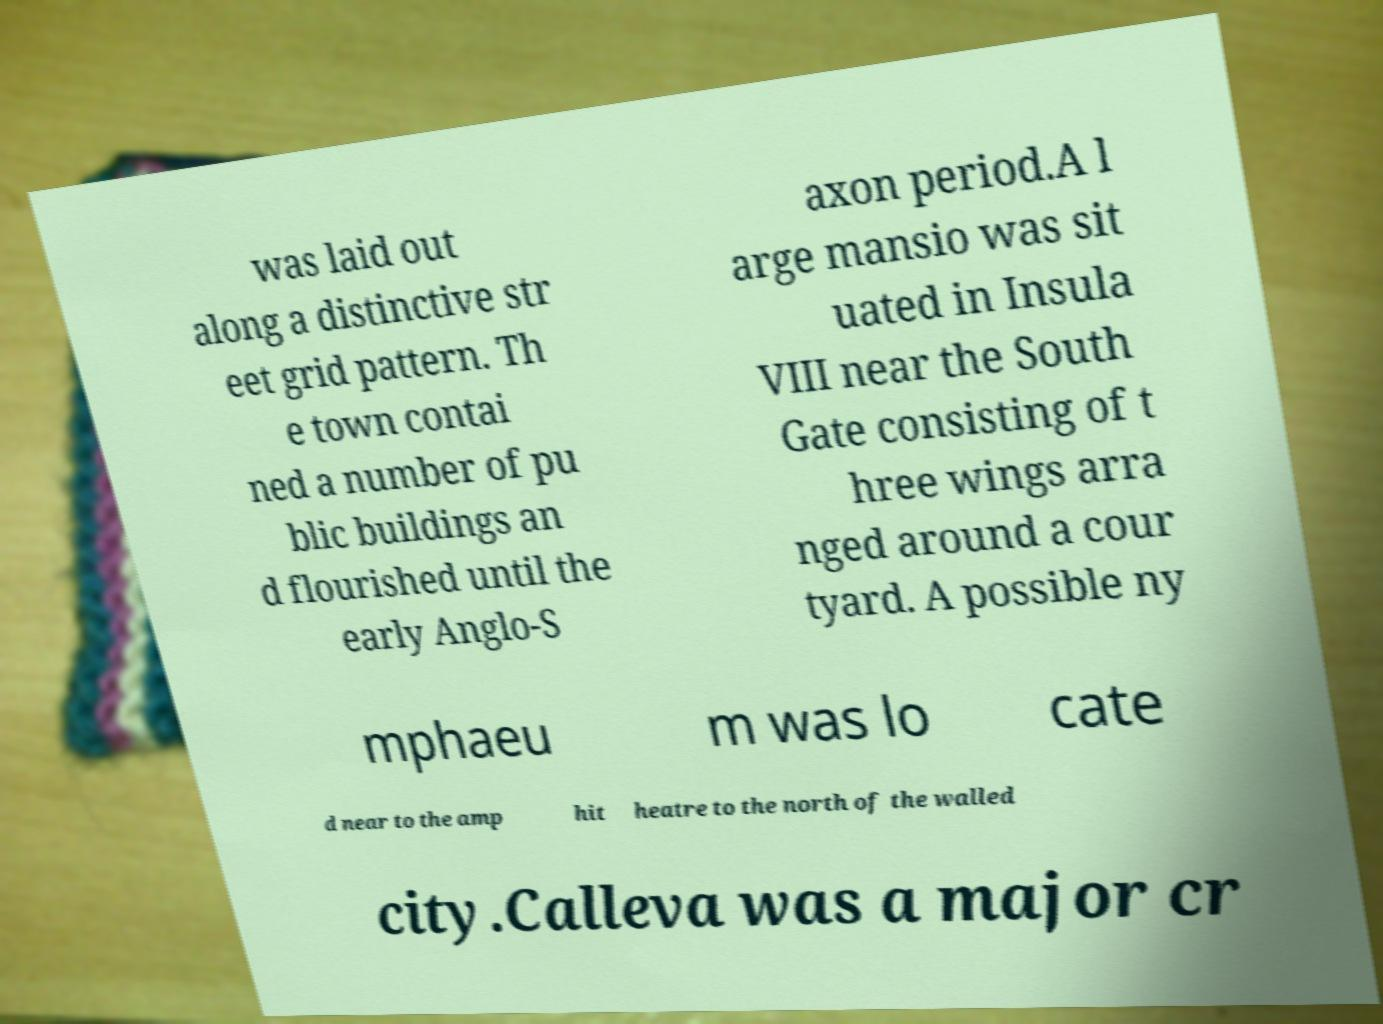What messages or text are displayed in this image? I need them in a readable, typed format. was laid out along a distinctive str eet grid pattern. Th e town contai ned a number of pu blic buildings an d flourished until the early Anglo-S axon period.A l arge mansio was sit uated in Insula VIII near the South Gate consisting of t hree wings arra nged around a cour tyard. A possible ny mphaeu m was lo cate d near to the amp hit heatre to the north of the walled city.Calleva was a major cr 